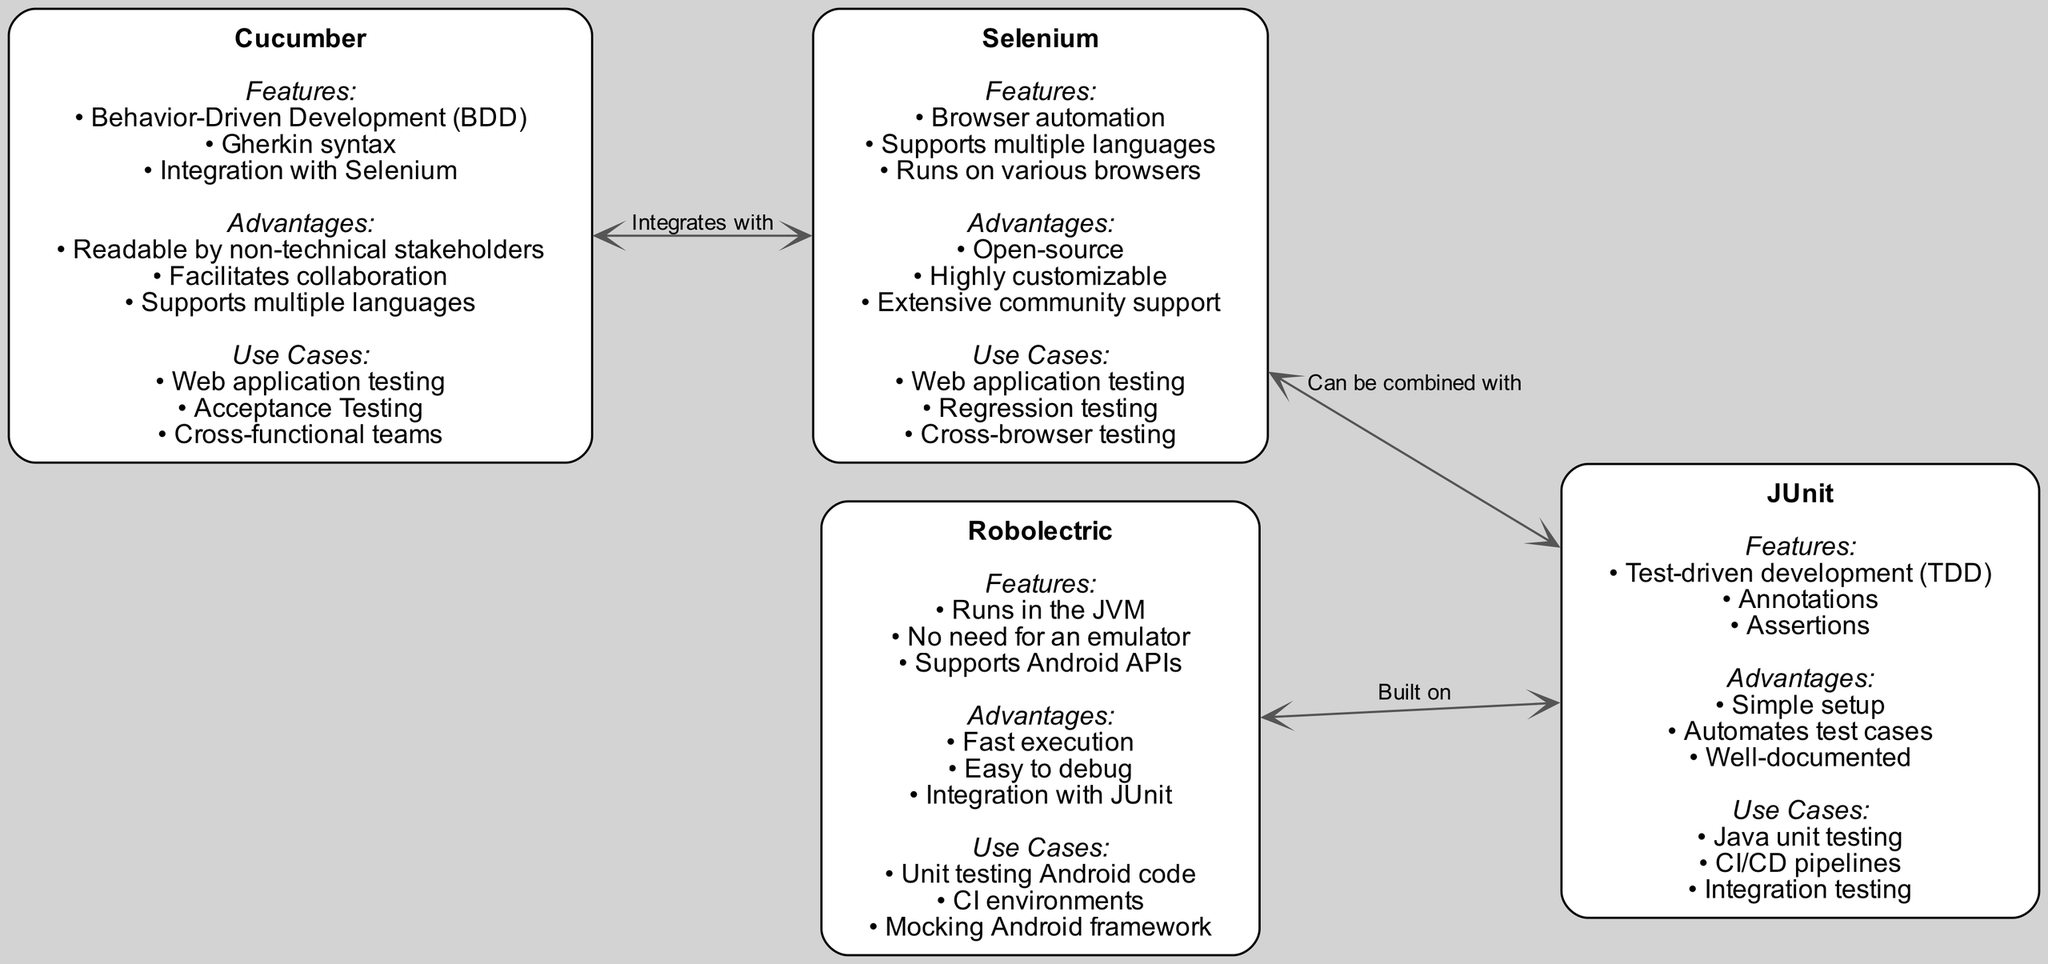What are the features of Cucumber? The diagram lists three key features under the Cucumber node: Behavior-Driven Development (BDD), Gherkin syntax, and Integration with Selenium.
Answer: Behavior-Driven Development (BDD), Gherkin syntax, Integration with Selenium How many nodes are represented in the diagram? By counting the unique nodes present in the diagram, there are four nodes: Cucumber, Robolectric, Selenium, and JUnit.
Answer: 4 What is the primary advantage of Selenium? Under the Selenium node, it is mentioned that it is open-source, highly customizable, and has extensive community support. The first listed advantage gives the answer.
Answer: Open-source Which testing framework can be used for unit testing Android code? The use cases for the Robolectric node specifically mention unit testing Android code as one of its applications.
Answer: Robolectric How does Robolectric relate to JUnit in the diagram? The diagram indicates that Robolectric is built on JUnit, showing a direct relationship between the two frameworks.
Answer: Built on What is a use case for Cucumber? The Cucumber node highlights three use cases, one of which is "Acceptance Testing." This directly answers the question about its use cases.
Answer: Acceptance Testing What type of development does JUnit support? JUnit features a focus on Test-Driven Development (TDD), which is explicitly mentioned under its features in the diagram.
Answer: Test-Driven Development (TDD) What integration does Cucumber support? The edges in the diagram show that Cucumber integrates with Selenium, indicating a direct connection and support for it.
Answer: Integrates with Selenium Which automated testing framework is associated with fast execution? The advantages listed under the Robolectric node specifically mention that it has fast execution, which answers the question concisely.
Answer: Robolectric 